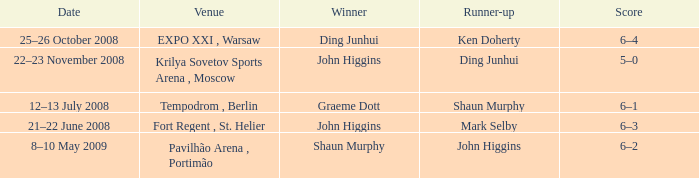Who was the winner in the match that had John Higgins as runner-up? Shaun Murphy. 